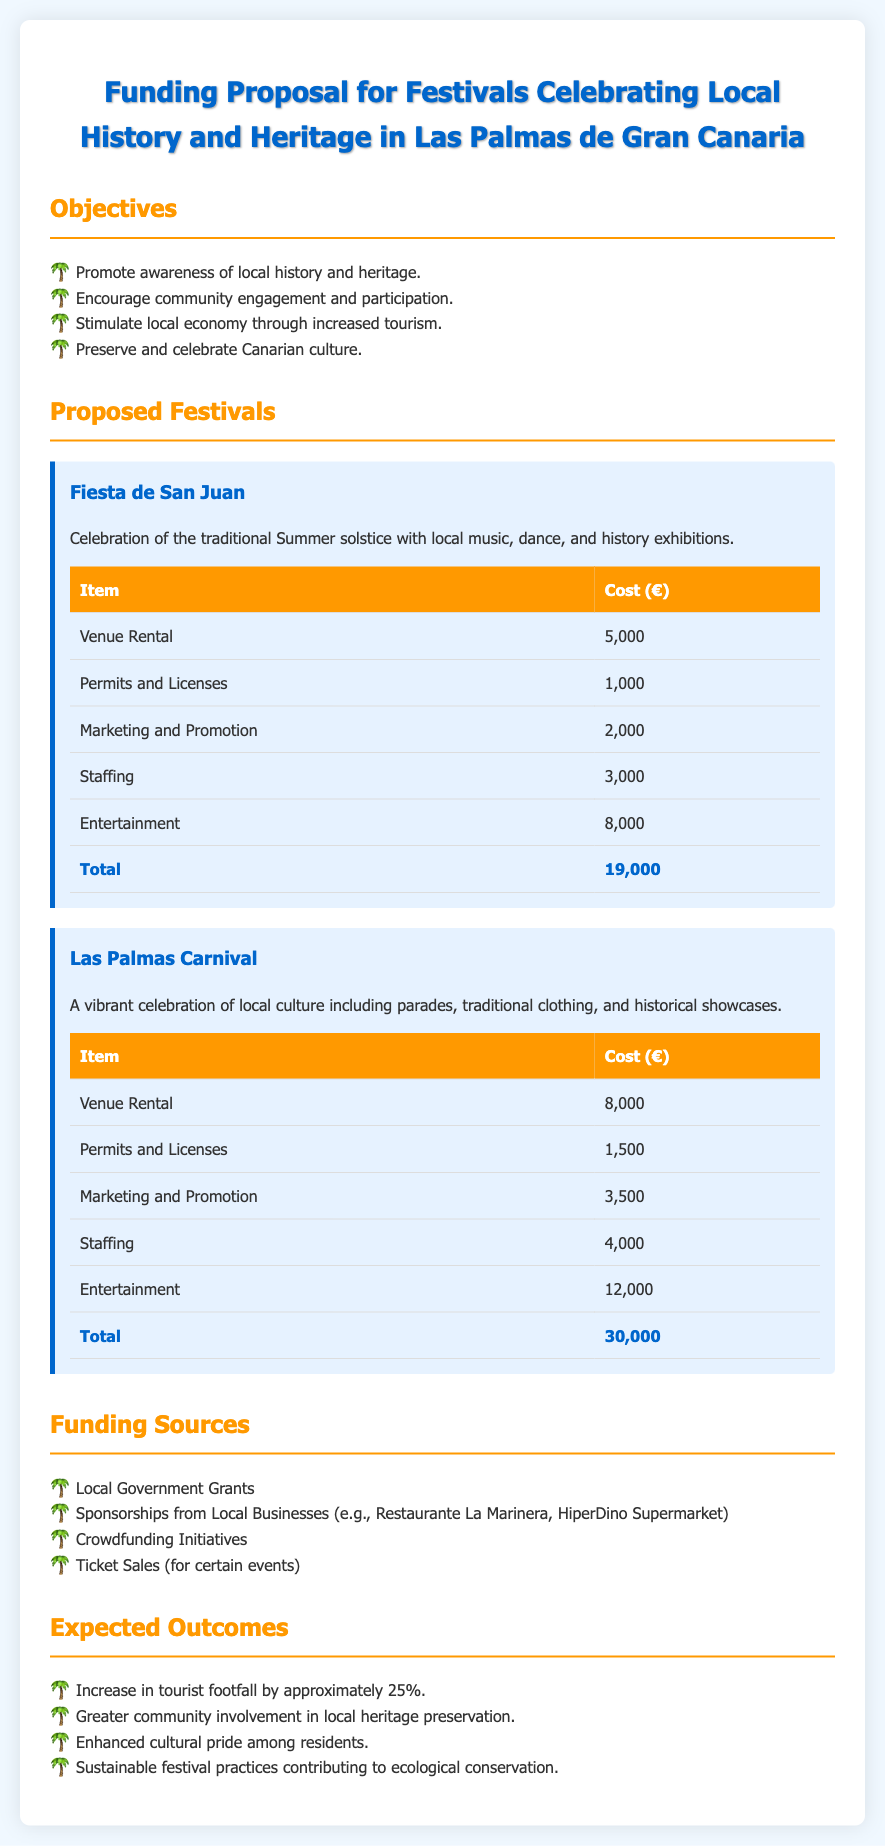What is the total cost for the Fiesta de San Juan? The total cost is listed in the table under the Fiesta de San Juan section, which is 19,000 euros.
Answer: 19,000 euros What is the cost for Marketing and Promotion for the Las Palmas Carnival? The cost for Marketing and Promotion can be found in the Las Palmas Carnival table, which states it is 3,500 euros.
Answer: 3,500 euros How many objectives are listed in the document? The number of objectives can be counted from the Objectives section, where four objectives are listed.
Answer: Four What is one funding source mentioned in the document? A funding source is any of the listed items under Funding Sources; one example is Local Government Grants.
Answer: Local Government Grants What theme does the Fiesta de San Juan celebrate? The theme is specified in the description, which mentions celebrating the traditional Summer solstice.
Answer: Summer solstice What is the total cost for the Las Palmas Carnival? The total cost for the carnival is noted in the table under the Las Palmas Carnival section, which is 30,000 euros.
Answer: 30,000 euros What is the expected increase in tourist footfall percentage? The expected percentage increase is mentioned under Expected Outcomes, stating approximately 25%.
Answer: 25% How many festivals are proposed in the document? The number of festivals can be counted from the Proposed Festivals section, where two festivals are mentioned.
Answer: Two 